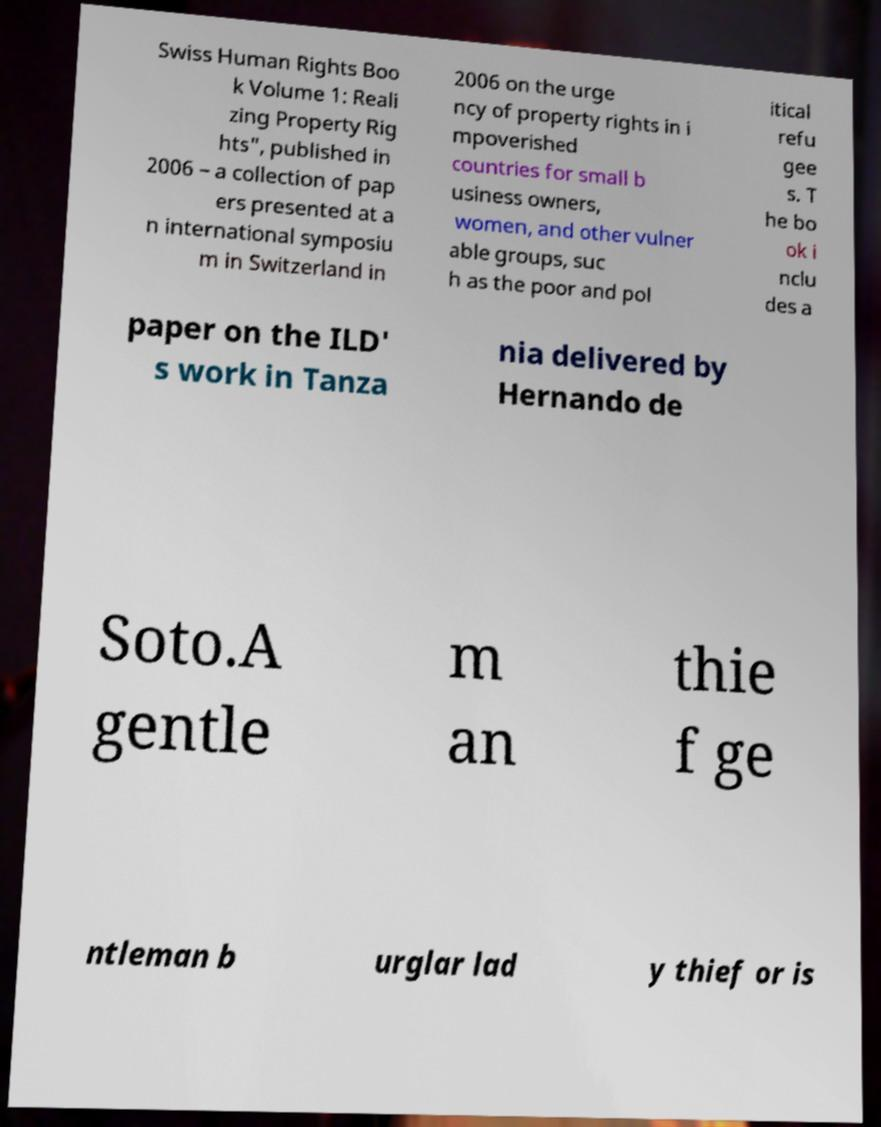Can you accurately transcribe the text from the provided image for me? Swiss Human Rights Boo k Volume 1: Reali zing Property Rig hts", published in 2006 – a collection of pap ers presented at a n international symposiu m in Switzerland in 2006 on the urge ncy of property rights in i mpoverished countries for small b usiness owners, women, and other vulner able groups, suc h as the poor and pol itical refu gee s. T he bo ok i nclu des a paper on the ILD' s work in Tanza nia delivered by Hernando de Soto.A gentle m an thie f ge ntleman b urglar lad y thief or is 